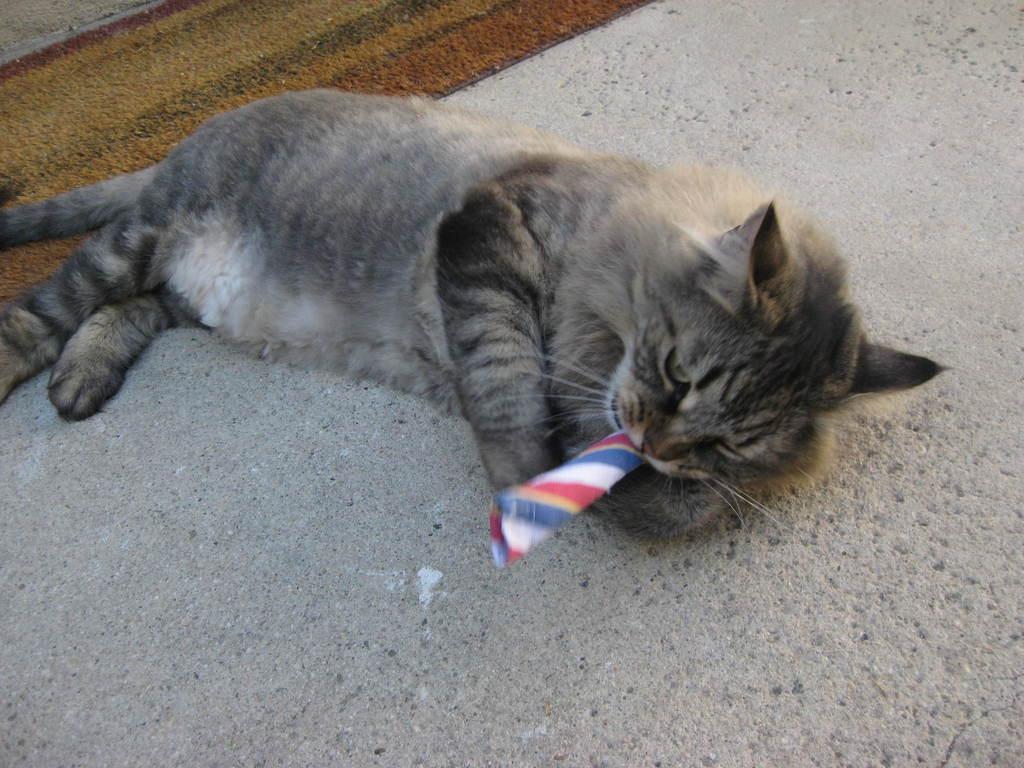Describe this image in one or two sentences. In this image I can see a cat is lying on the ground and I can also see a colourful thing in the cat's mouth. On the top left side of this image I can see a brown colour floor mattress. 